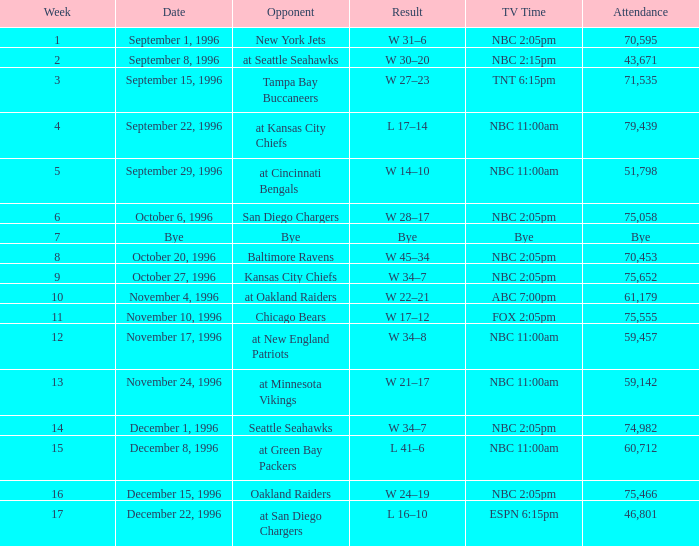What is the week with a participation of 75,555? 11.0. 